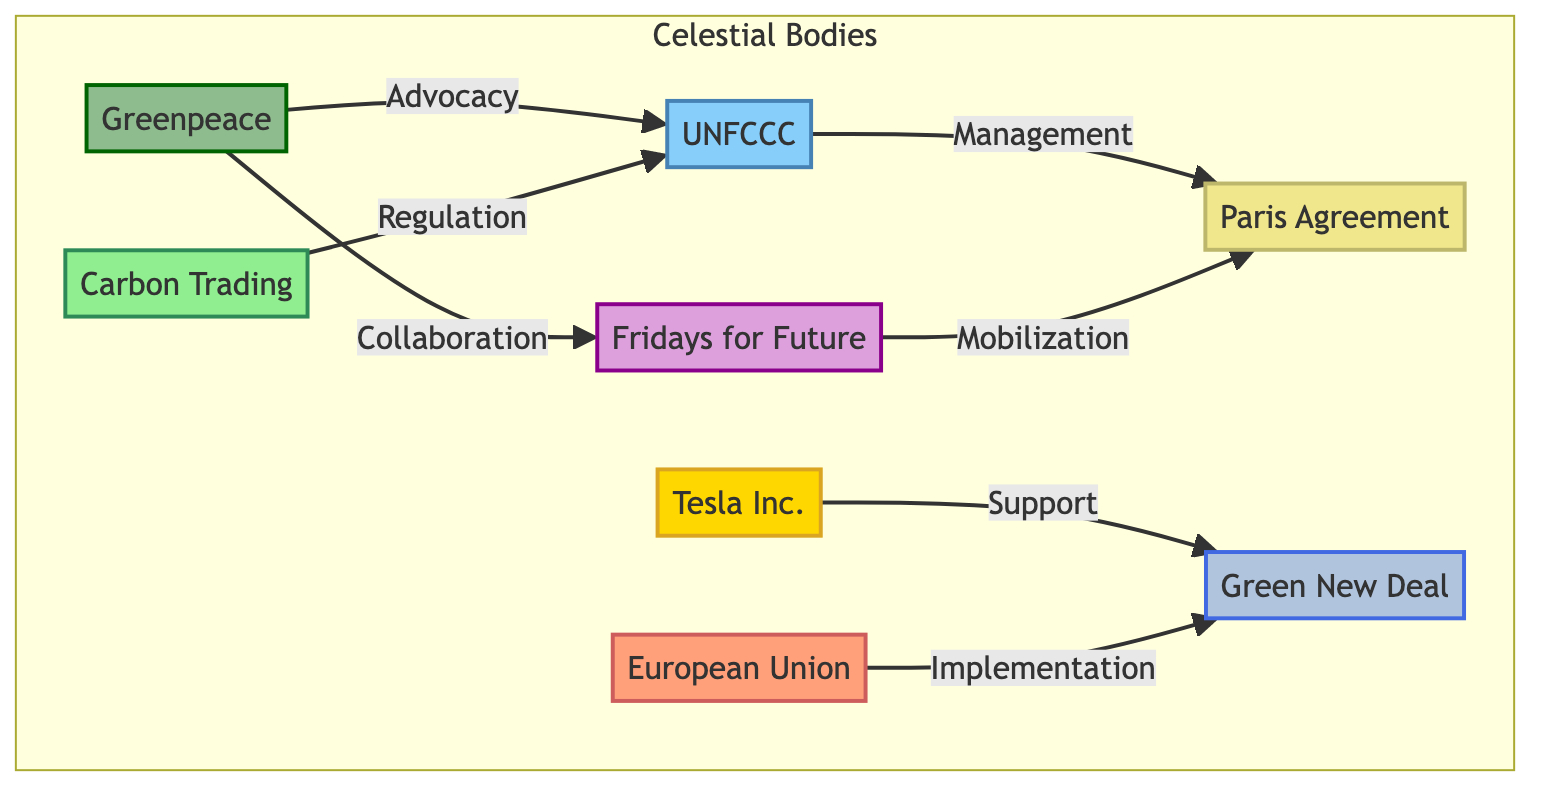What is the role of Greenpeace in the diagram? In the diagram, Greenpeace is represented as the node "NGO1," which is associated with advocacy towards the International Organization UNFCCC. This establishes Greenpeace's role as promoting climate action through collaboration and influence on international policies.
Answer: Advocacy Which organization directly supports the Green New Deal? Tesla Inc. is shown in the diagram as the node "Corp1," which has a direct edge labeled "Support" leading to the "Green New Deal" node. This indicates that Tesla Inc. is actively involved in supporting this particular policy initiative.
Answer: Tesla Inc How many nodes represent non-governmental organizations? The nodes representing non-governmental organizations in the diagram are Greenpeace, Fridays for Future, and UNFCCC. Counting these nodes gives a total of 3 non-governmental organizations identified in the diagram.
Answer: 3 What is the relationship between Fridays for Future and the Paris Agreement? The diagram illustrates that Fridays for Future (CSG1) is connected to the Paris Agreement (Event1) with an edge labeled "Mobilization." This indicates that Fridays for Future plays a role in mobilizing support or actions related to the Paris Agreement.
Answer: Mobilization Which node indicates the role of international regulation? The node labeled "Econ1," which represents "Carbon Trading," has an edge leading to the International Organization (IntOrg1) with the label "Regulation." This shows that the role of international regulation is represented by the trading of carbon as a regulatory mechanism.
Answer: Carbon Trading How does the European Union influence the Green New Deal? According to the diagram, the European Union (Gov1) has an "Implementation" relationship leading to the Green New Deal (Policy1). This indicates that the European Union influences this policy through its implementation efforts.
Answer: Implementation Which type of organizations are connected to the Paris Agreement? The diagram connects both non-governmental organizations (Fridays for Future) and intergovernmental organizations (UNFCCC) to the Paris Agreement, indicating that both types of organizations are involved in this global climate initiative.
Answer: Non-governmental and intergovernmental organizations How many edges connect the non-governmental organizations to the International Organization? There are two edges connecting non-governmental organizations (Greenpeace and Fridays for Future) to the International Organization (UNFCCC). The first edge is labeled "Advocacy," and the second edge is represented by the influence of economic regulation. Counting these gives a total of 2 edges.
Answer: 2 